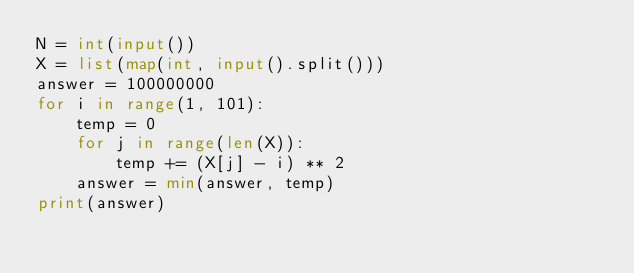Convert code to text. <code><loc_0><loc_0><loc_500><loc_500><_Python_>N = int(input())
X = list(map(int, input().split()))
answer = 100000000
for i in range(1, 101):
    temp = 0
    for j in range(len(X)):
        temp += (X[j] - i) ** 2
    answer = min(answer, temp)
print(answer)
</code> 